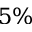Convert formula to latex. <formula><loc_0><loc_0><loc_500><loc_500>5 \%</formula> 